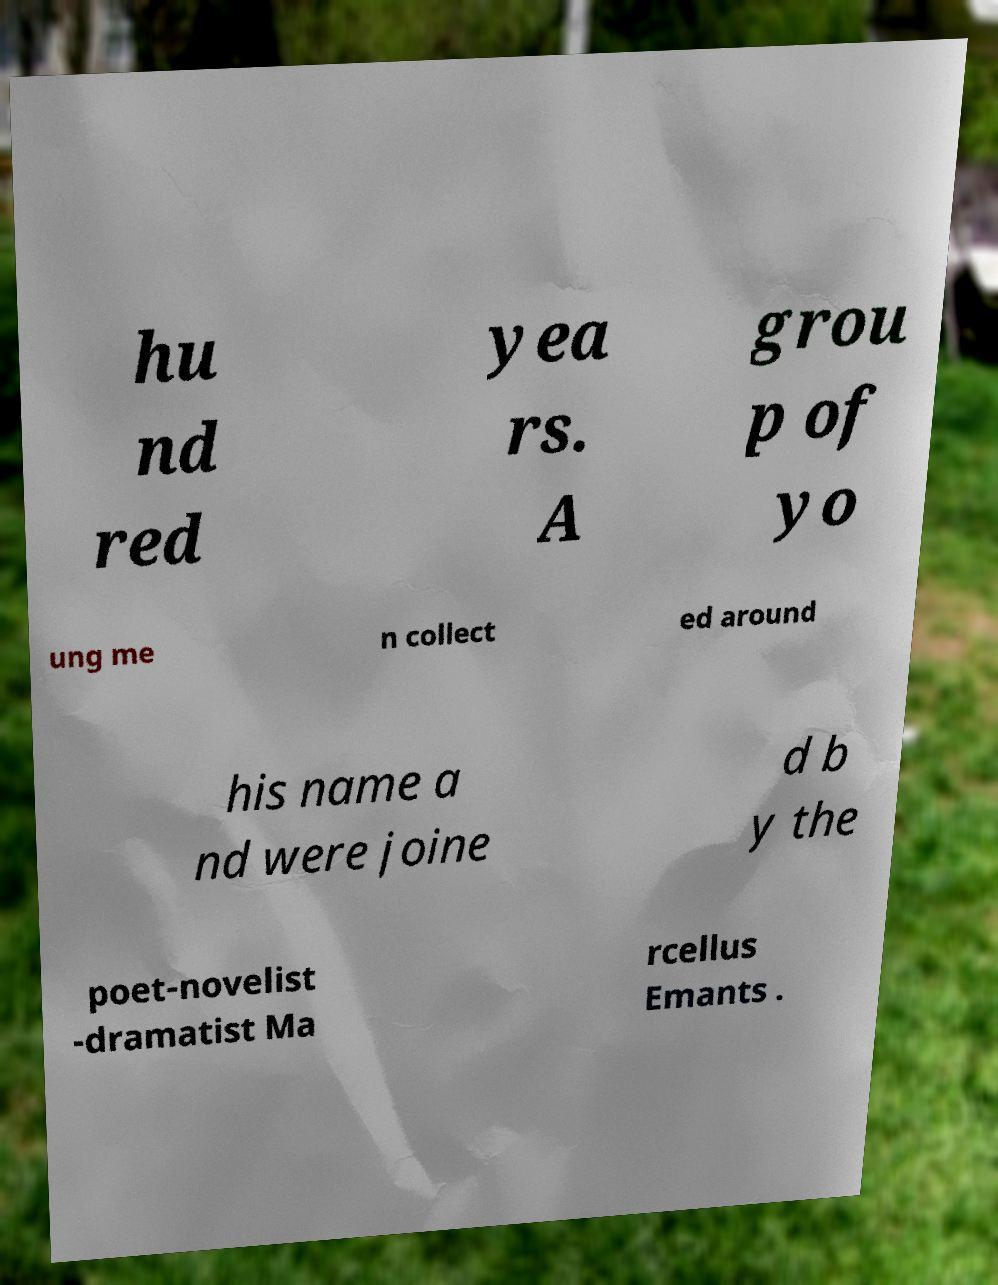Can you read and provide the text displayed in the image?This photo seems to have some interesting text. Can you extract and type it out for me? hu nd red yea rs. A grou p of yo ung me n collect ed around his name a nd were joine d b y the poet-novelist -dramatist Ma rcellus Emants . 